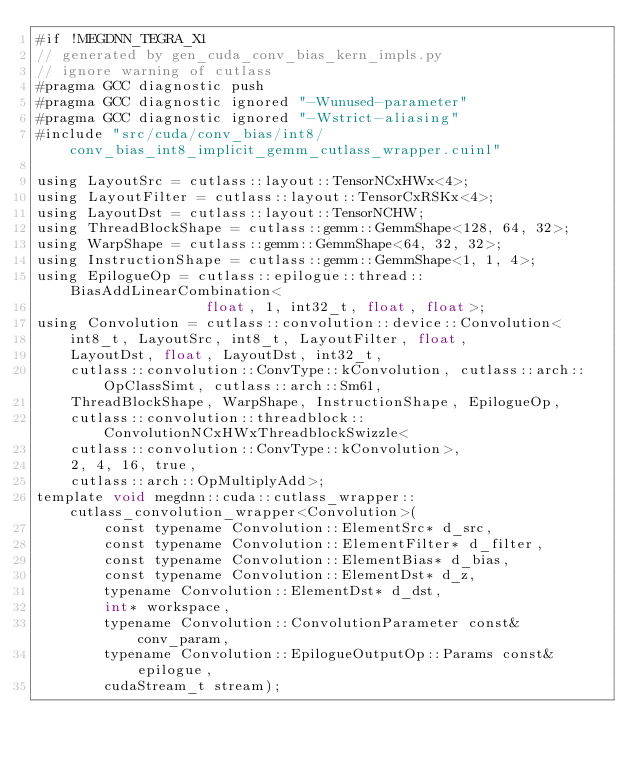<code> <loc_0><loc_0><loc_500><loc_500><_Cuda_>#if !MEGDNN_TEGRA_X1
// generated by gen_cuda_conv_bias_kern_impls.py
// ignore warning of cutlass
#pragma GCC diagnostic push
#pragma GCC diagnostic ignored "-Wunused-parameter"
#pragma GCC diagnostic ignored "-Wstrict-aliasing"
#include "src/cuda/conv_bias/int8/conv_bias_int8_implicit_gemm_cutlass_wrapper.cuinl"

using LayoutSrc = cutlass::layout::TensorNCxHWx<4>;
using LayoutFilter = cutlass::layout::TensorCxRSKx<4>;
using LayoutDst = cutlass::layout::TensorNCHW;
using ThreadBlockShape = cutlass::gemm::GemmShape<128, 64, 32>;
using WarpShape = cutlass::gemm::GemmShape<64, 32, 32>;
using InstructionShape = cutlass::gemm::GemmShape<1, 1, 4>;
using EpilogueOp = cutlass::epilogue::thread::BiasAddLinearCombination<
                    float, 1, int32_t, float, float>;
using Convolution = cutlass::convolution::device::Convolution<
    int8_t, LayoutSrc, int8_t, LayoutFilter, float, 
    LayoutDst, float, LayoutDst, int32_t, 
    cutlass::convolution::ConvType::kConvolution, cutlass::arch::OpClassSimt, cutlass::arch::Sm61, 
    ThreadBlockShape, WarpShape, InstructionShape, EpilogueOp, 
    cutlass::convolution::threadblock::ConvolutionNCxHWxThreadblockSwizzle<
    cutlass::convolution::ConvType::kConvolution>, 
    2, 4, 16, true, 
    cutlass::arch::OpMultiplyAdd>;
template void megdnn::cuda::cutlass_wrapper::cutlass_convolution_wrapper<Convolution>(
        const typename Convolution::ElementSrc* d_src, 
        const typename Convolution::ElementFilter* d_filter, 
        const typename Convolution::ElementBias* d_bias, 
        const typename Convolution::ElementDst* d_z, 
        typename Convolution::ElementDst* d_dst, 
        int* workspace, 
        typename Convolution::ConvolutionParameter const& conv_param, 
        typename Convolution::EpilogueOutputOp::Params const& epilogue, 
        cudaStream_t stream);</code> 